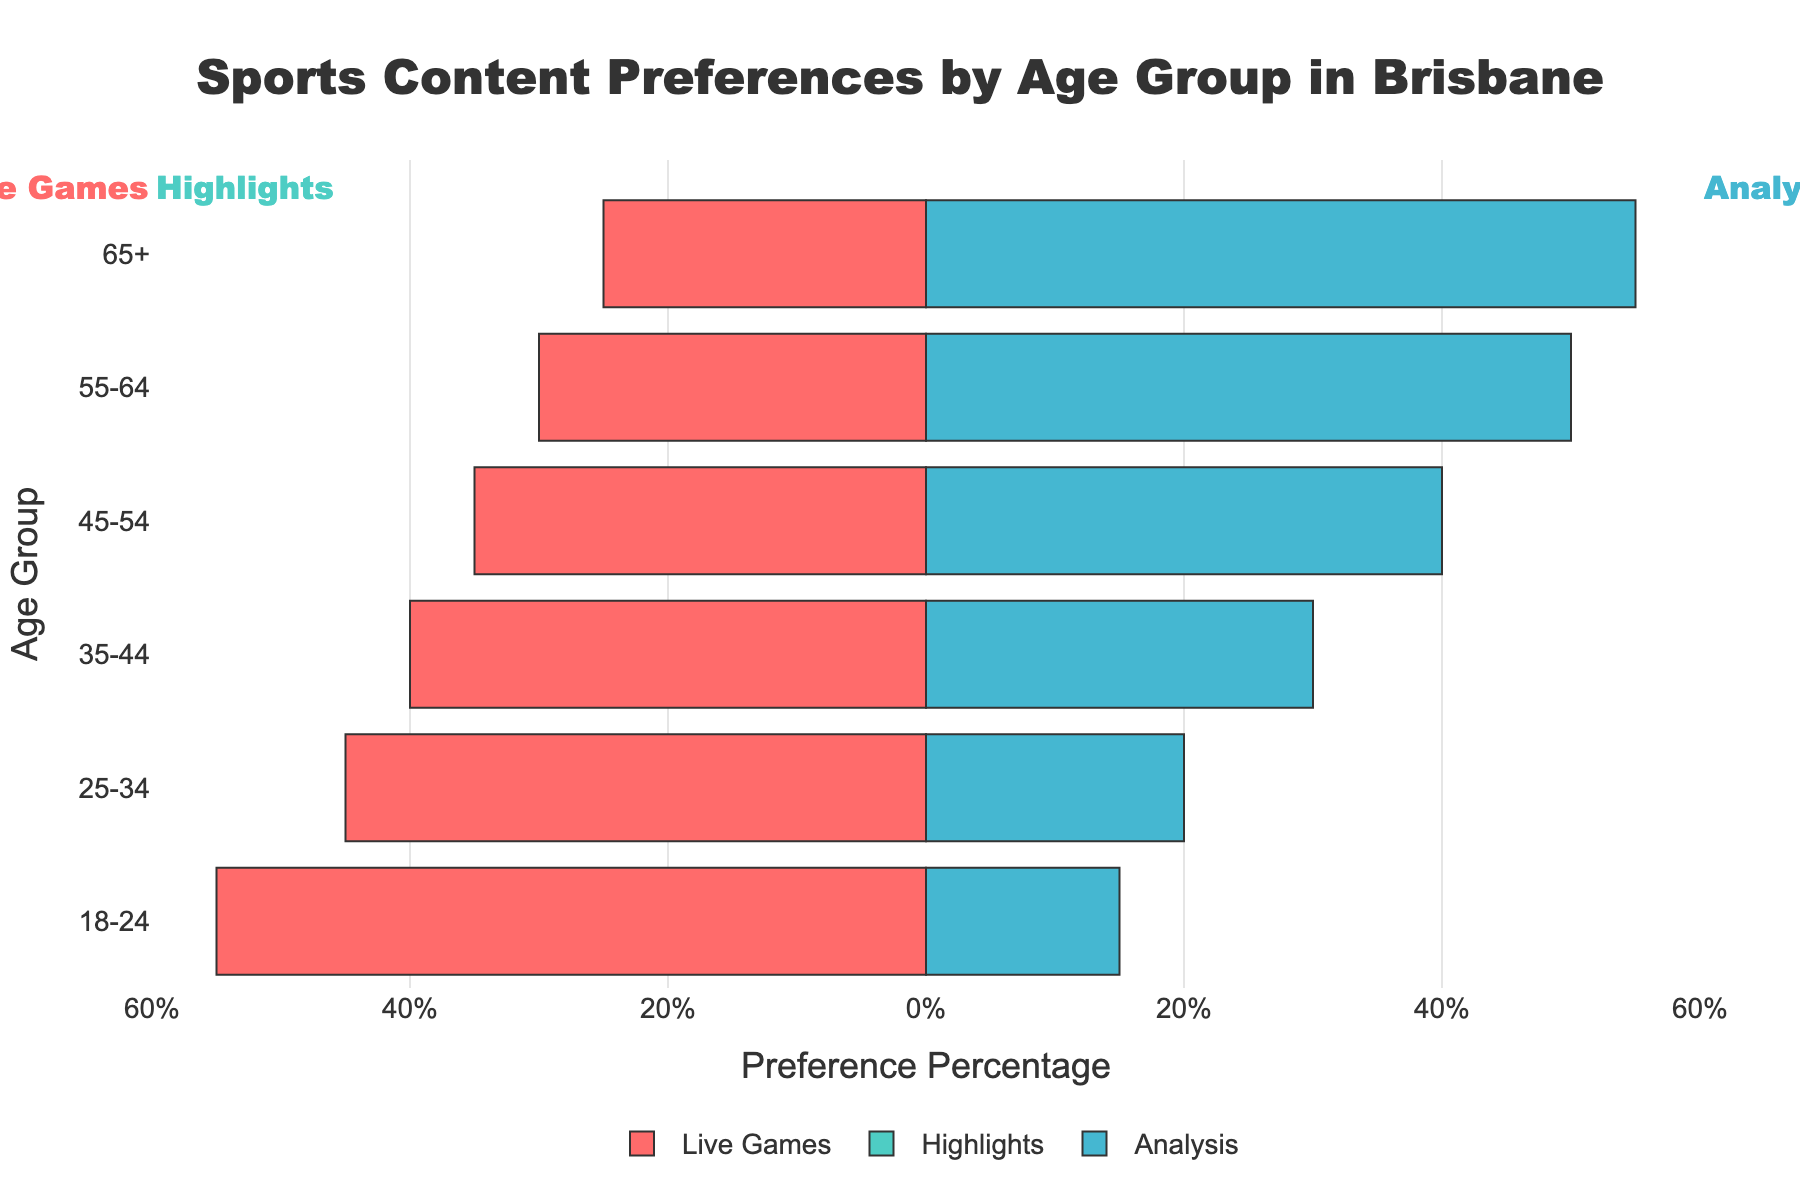What percentage of the 18-24 age group prefers highlights? Look at the segment representing the 18-24 age group and refer to the highlights category. The preference is stated as 30%.
Answer: 30% Which age group has the highest preference for analysis content? Compare the segments of each age group for analysis content. The highest preference for analysis content is shown in the 65+ age group with 55%.
Answer: 65+ How does the preference for live games change as the age group increases from 18-24 to 65+? Observe the live games segments for each age group. The preferences are 55%, 45%, 40%, 35%, 30%, and 25% respectively, showing a decreasing trend as the age groups increase.
Answer: Decreases Which age group has the most balanced preferences between all three content types? Check the percentages for live games, highlights, and analysis for each age group. The 35-44 age group has close percentages of 40% for live games, 30% for highlights, and 30% for analysis.
Answer: 35-44 Comparing the 25-34 and 45-54 age groups, which one has a higher preference for highlights? Look at the highlights segment for both 25-34 and 45-54 age groups. The 25-34 age group shows a 35% preference, while the 45-54 age group shows a 25% preference.
Answer: 25-34 What is the difference in preference for live games between the youngest (18-24) and oldest (65+) age groups? Subtract the preference percentage of the 65+ age group from the 18-24 age group for live games. The difference is 55% - 25% = 30%.
Answer: 30% Which content type is least preferred by the 55-64 age group? Compare the percentages for all three content types for the 55-64 age group. The least preferred is highlights at 20%.
Answer: Highlights For the age group 45-54, how much greater is the preference for analysis compared to highlights? Subtract the percentage of highlights from that of analysis for the 45-54 age group. The difference is 40% - 25% = 15%.
Answer: 15% What is the combined preference percentage for highlights across all age groups? Add the preferences for highlights for all age groups: 30% (18-24) + 35% (25-34) + 30% (35-44) + 25% (45-54) + 20% (55-64) + 20% (65+) = 160%.
Answer: 160% Which content type consistently decreases in preference as the age group increases? Compare the preferences for each content type across the age groups to see which one consistently decreases. Live games show a consistent decrease from 55% to 25% as age increases.
Answer: Live games 